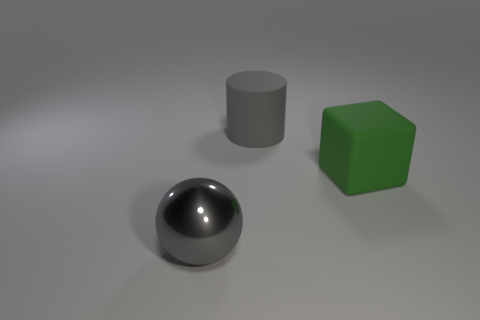Add 2 small brown matte cubes. How many objects exist? 5 Subtract all blocks. How many objects are left? 2 Add 3 large green rubber balls. How many large green rubber balls exist? 3 Subtract 0 purple cylinders. How many objects are left? 3 Subtract all large purple rubber cylinders. Subtract all big gray metal spheres. How many objects are left? 2 Add 3 gray spheres. How many gray spheres are left? 4 